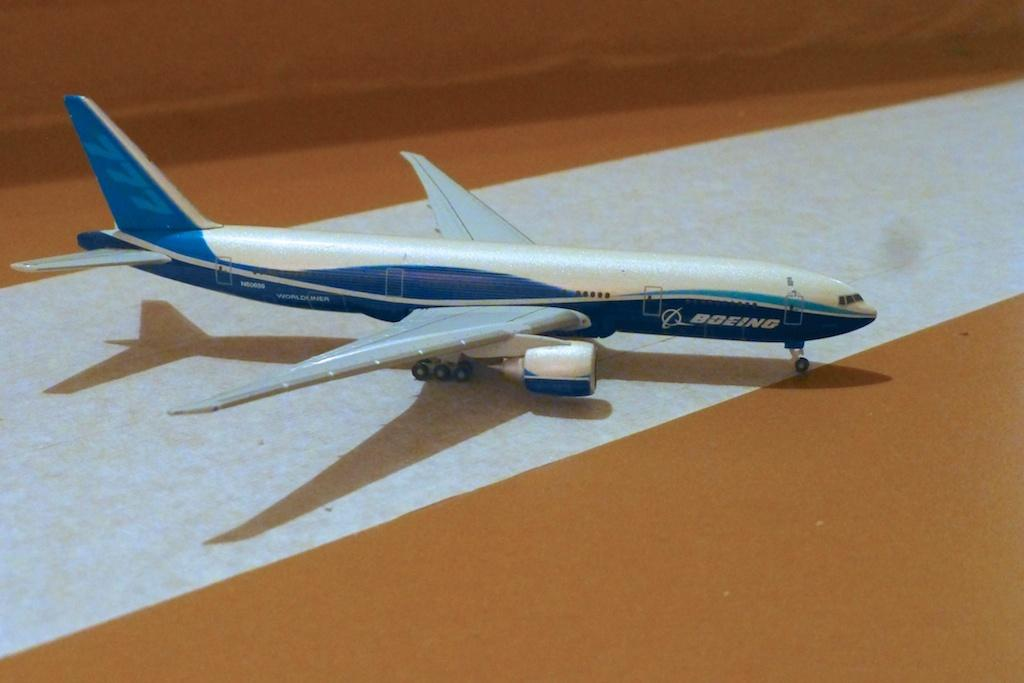What type of toy is in the image? There is an airplane toy in the image. Where is the airplane toy located? The airplane toy is on the floor. What colors are used for the airplane toy? The airplane toy is blue and white in color. What type of guitar can be seen in the image? There is no guitar present in the image; it features an airplane toy. What shape is the square object in the image? There is no square object present in the image. 